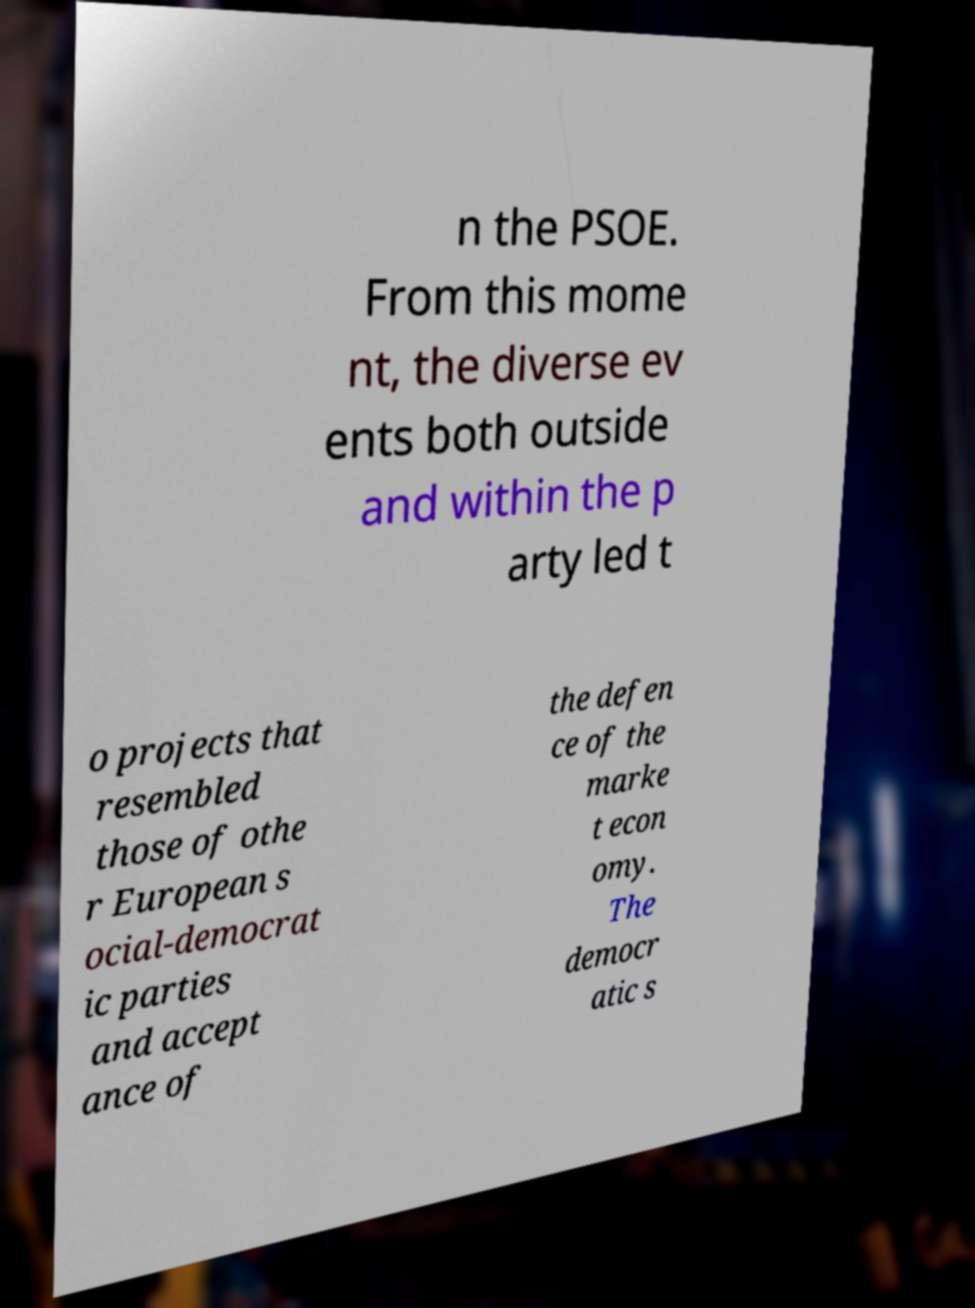Can you accurately transcribe the text from the provided image for me? n the PSOE. From this mome nt, the diverse ev ents both outside and within the p arty led t o projects that resembled those of othe r European s ocial-democrat ic parties and accept ance of the defen ce of the marke t econ omy. The democr atic s 